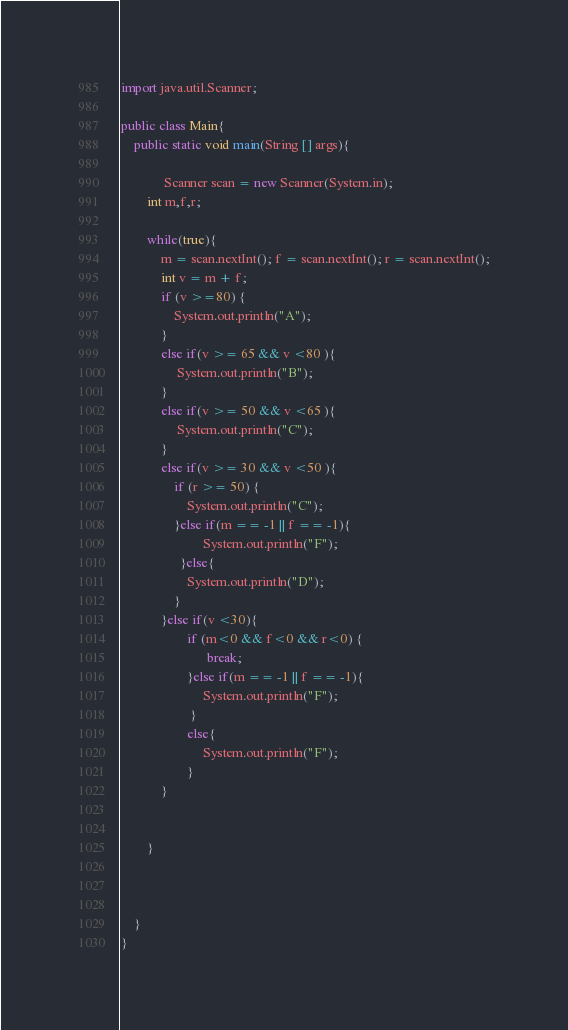<code> <loc_0><loc_0><loc_500><loc_500><_Java_>import java.util.Scanner;

public class Main{
    public static void main(String [] args){
       
             Scanner scan = new Scanner(System.in);
        int m,f,r;
        
        while(true){
            m = scan.nextInt(); f = scan.nextInt(); r = scan.nextInt();
            int v = m + f;
            if (v >=80) {
                System.out.println("A");
            }
            else if(v >= 65 && v <80 ){
                 System.out.println("B");
            }
            else if(v >= 50 && v <65 ){
                 System.out.println("C");
            }
            else if(v >= 30 && v <50 ){
                if (r >= 50) {
                    System.out.println("C");
                }else if(m == -1 || f == -1){
                         System.out.println("F");
                  }else{
                    System.out.println("D");
                }
            }else if(v <30){
                    if (m<0 && f<0 && r<0) {
                          break;
                    }else if(m == -1 || f == -1){
                         System.out.println("F");
                     }
                    else{
                         System.out.println("F");
                    }
            }
            
            
        }
            
            
        
    }
}
</code> 